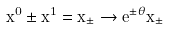<formula> <loc_0><loc_0><loc_500><loc_500>x ^ { 0 } \pm x ^ { 1 } = x _ { \pm } \rightarrow e ^ { \pm \theta } x _ { \pm }</formula> 